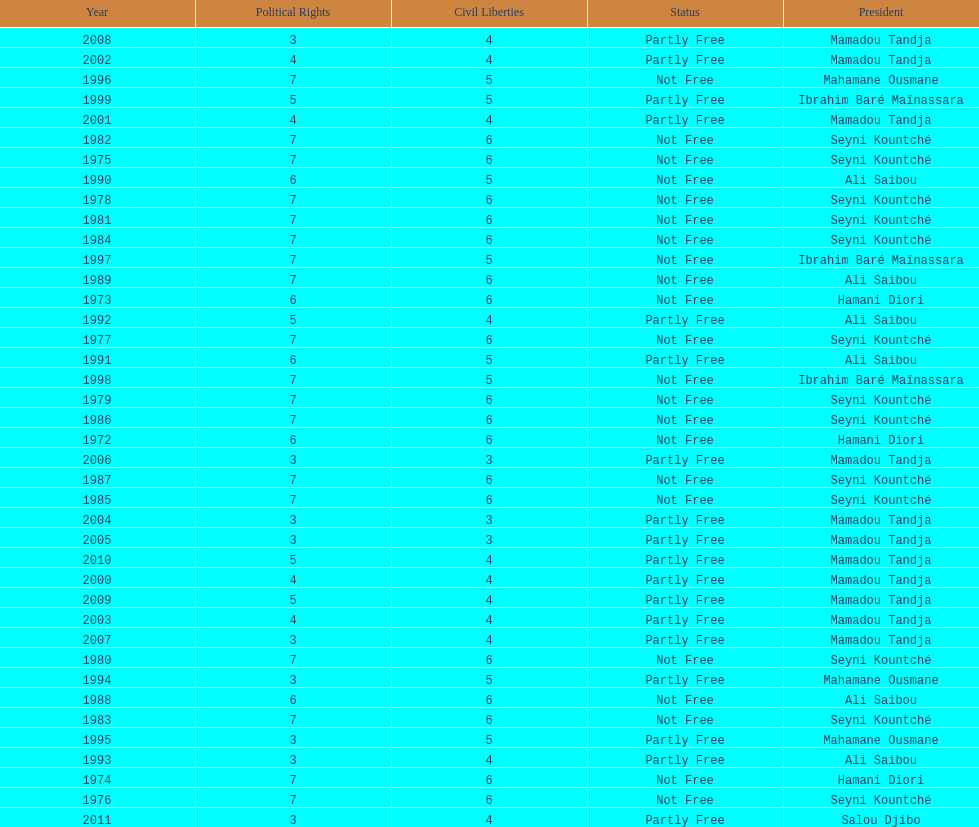Would you be able to parse every entry in this table? {'header': ['Year', 'Political Rights', 'Civil Liberties', 'Status', 'President'], 'rows': [['2008', '3', '4', 'Partly Free', 'Mamadou Tandja'], ['2002', '4', '4', 'Partly Free', 'Mamadou Tandja'], ['1996', '7', '5', 'Not Free', 'Mahamane Ousmane'], ['1999', '5', '5', 'Partly Free', 'Ibrahim Baré Maïnassara'], ['2001', '4', '4', 'Partly Free', 'Mamadou Tandja'], ['1982', '7', '6', 'Not Free', 'Seyni Kountché'], ['1975', '7', '6', 'Not Free', 'Seyni Kountché'], ['1990', '6', '5', 'Not Free', 'Ali Saibou'], ['1978', '7', '6', 'Not Free', 'Seyni Kountché'], ['1981', '7', '6', 'Not Free', 'Seyni Kountché'], ['1984', '7', '6', 'Not Free', 'Seyni Kountché'], ['1997', '7', '5', 'Not Free', 'Ibrahim Baré Maïnassara'], ['1989', '7', '6', 'Not Free', 'Ali Saibou'], ['1973', '6', '6', 'Not Free', 'Hamani Diori'], ['1992', '5', '4', 'Partly Free', 'Ali Saibou'], ['1977', '7', '6', 'Not Free', 'Seyni Kountché'], ['1991', '6', '5', 'Partly Free', 'Ali Saibou'], ['1998', '7', '5', 'Not Free', 'Ibrahim Baré Maïnassara'], ['1979', '7', '6', 'Not Free', 'Seyni Kountché'], ['1986', '7', '6', 'Not Free', 'Seyni Kountché'], ['1972', '6', '6', 'Not Free', 'Hamani Diori'], ['2006', '3', '3', 'Partly Free', 'Mamadou Tandja'], ['1987', '7', '6', 'Not Free', 'Seyni Kountché'], ['1985', '7', '6', 'Not Free', 'Seyni Kountché'], ['2004', '3', '3', 'Partly Free', 'Mamadou Tandja'], ['2005', '3', '3', 'Partly Free', 'Mamadou Tandja'], ['2010', '5', '4', 'Partly Free', 'Mamadou Tandja'], ['2000', '4', '4', 'Partly Free', 'Mamadou Tandja'], ['2009', '5', '4', 'Partly Free', 'Mamadou Tandja'], ['2003', '4', '4', 'Partly Free', 'Mamadou Tandja'], ['2007', '3', '4', 'Partly Free', 'Mamadou Tandja'], ['1980', '7', '6', 'Not Free', 'Seyni Kountché'], ['1994', '3', '5', 'Partly Free', 'Mahamane Ousmane'], ['1988', '6', '6', 'Not Free', 'Ali Saibou'], ['1983', '7', '6', 'Not Free', 'Seyni Kountché'], ['1995', '3', '5', 'Partly Free', 'Mahamane Ousmane'], ['1993', '3', '4', 'Partly Free', 'Ali Saibou'], ['1974', '7', '6', 'Not Free', 'Hamani Diori'], ['1976', '7', '6', 'Not Free', 'Seyni Kountché'], ['2011', '3', '4', 'Partly Free', 'Salou Djibo']]} How many years was ali saibou president? 6. 